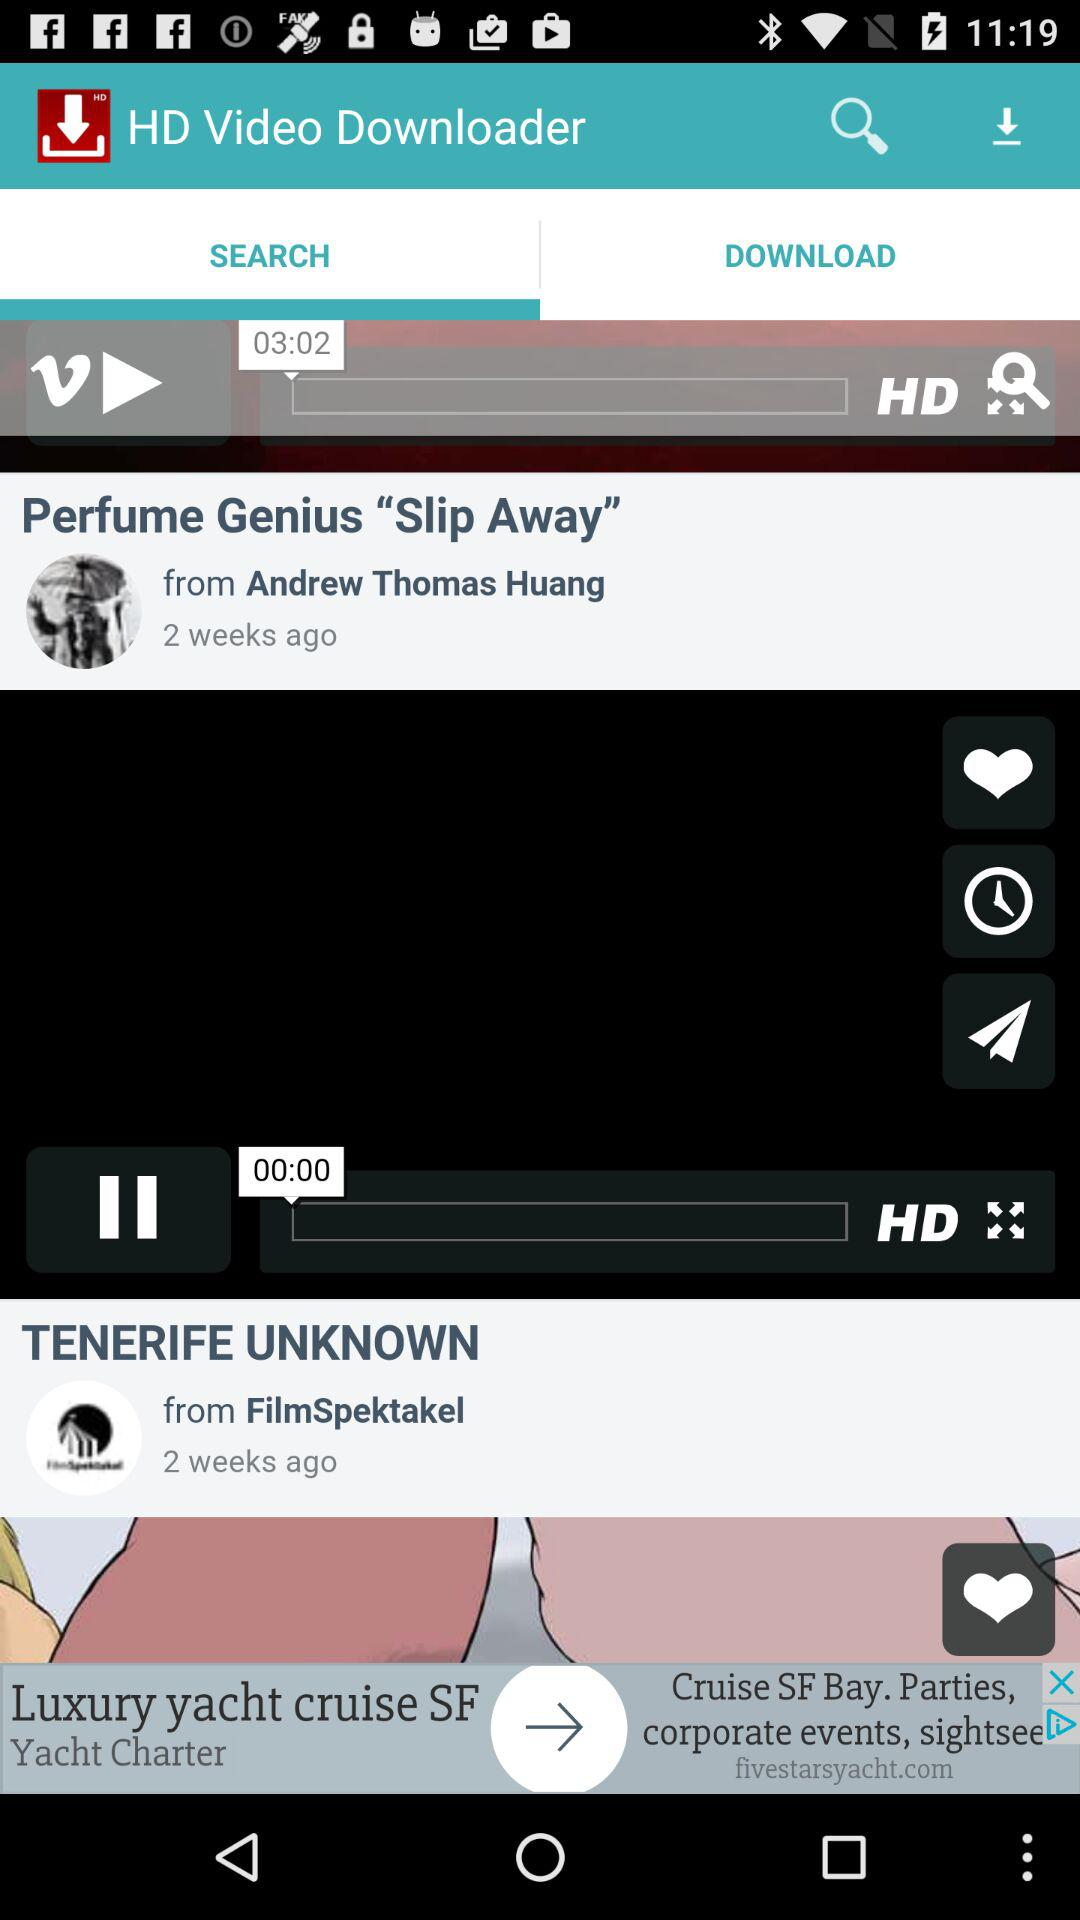Who is the author of "TENERIFE UNKNOWN"?
Answer the question using a single word or phrase. The author is "FilmSpektakel" 